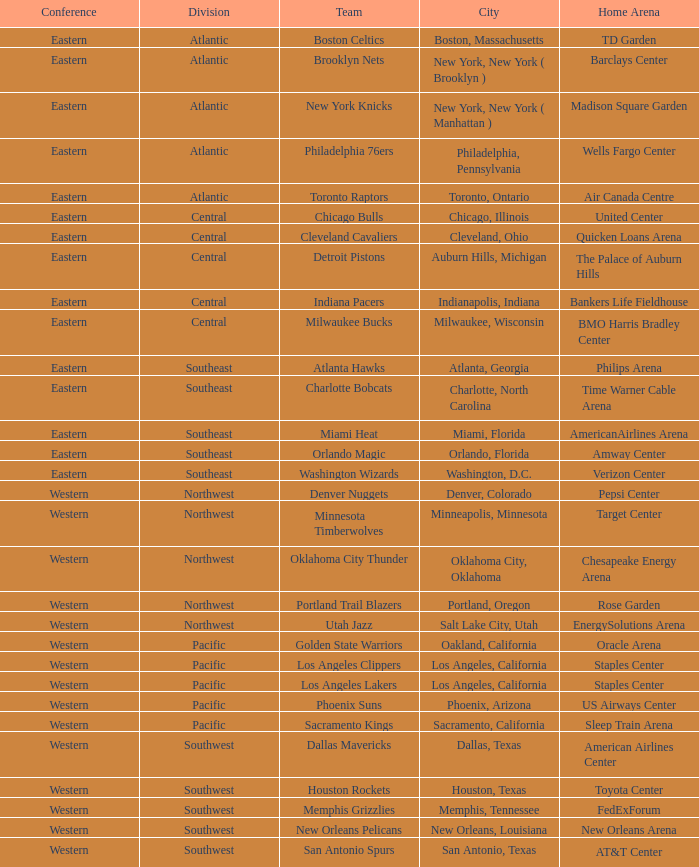Which team resides in the southeast with a home base at philips arena? Atlanta Hawks. 